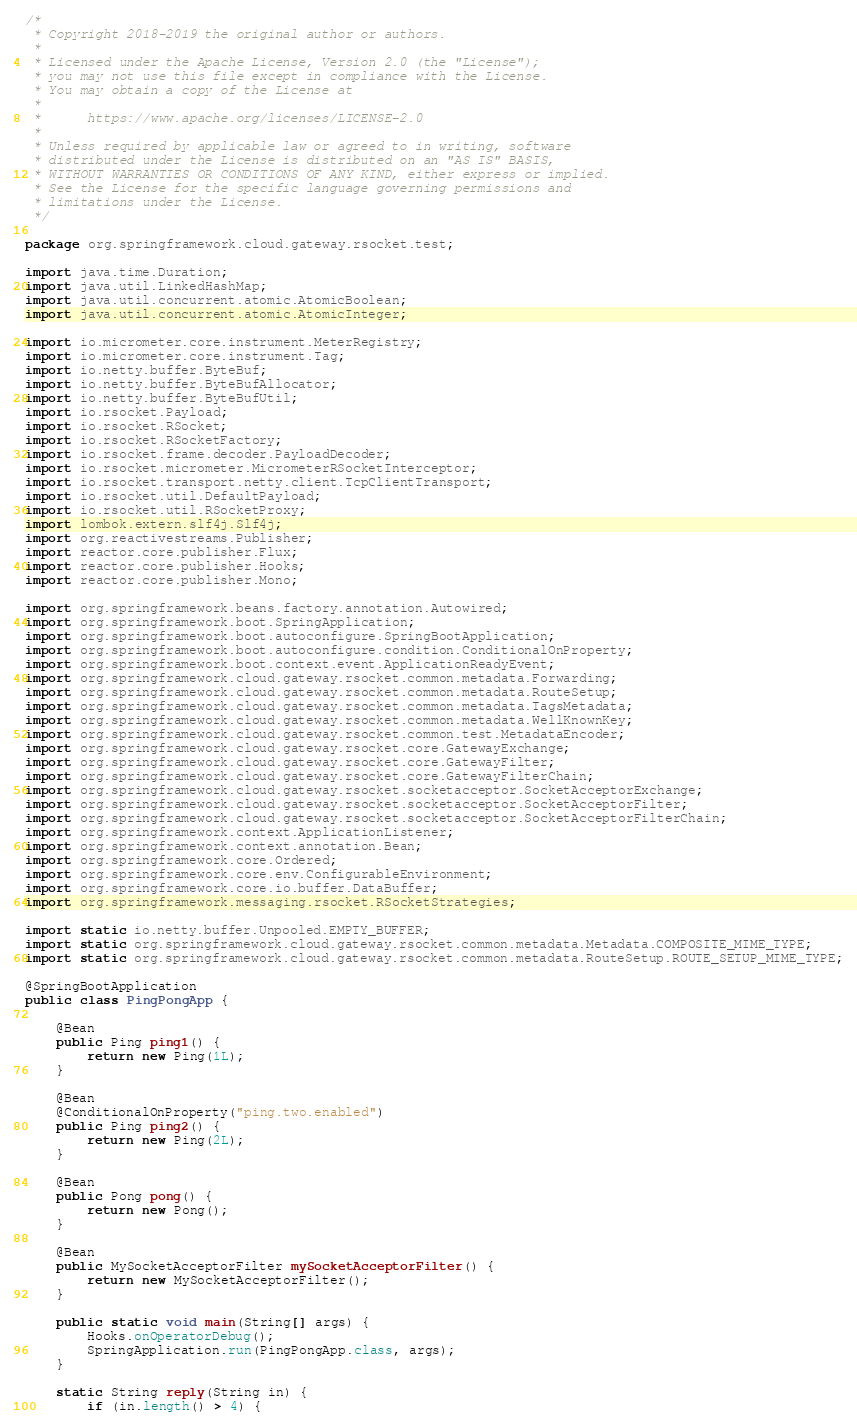Convert code to text. <code><loc_0><loc_0><loc_500><loc_500><_Java_>/*
 * Copyright 2018-2019 the original author or authors.
 *
 * Licensed under the Apache License, Version 2.0 (the "License");
 * you may not use this file except in compliance with the License.
 * You may obtain a copy of the License at
 *
 *      https://www.apache.org/licenses/LICENSE-2.0
 *
 * Unless required by applicable law or agreed to in writing, software
 * distributed under the License is distributed on an "AS IS" BASIS,
 * WITHOUT WARRANTIES OR CONDITIONS OF ANY KIND, either express or implied.
 * See the License for the specific language governing permissions and
 * limitations under the License.
 */

package org.springframework.cloud.gateway.rsocket.test;

import java.time.Duration;
import java.util.LinkedHashMap;
import java.util.concurrent.atomic.AtomicBoolean;
import java.util.concurrent.atomic.AtomicInteger;

import io.micrometer.core.instrument.MeterRegistry;
import io.micrometer.core.instrument.Tag;
import io.netty.buffer.ByteBuf;
import io.netty.buffer.ByteBufAllocator;
import io.netty.buffer.ByteBufUtil;
import io.rsocket.Payload;
import io.rsocket.RSocket;
import io.rsocket.RSocketFactory;
import io.rsocket.frame.decoder.PayloadDecoder;
import io.rsocket.micrometer.MicrometerRSocketInterceptor;
import io.rsocket.transport.netty.client.TcpClientTransport;
import io.rsocket.util.DefaultPayload;
import io.rsocket.util.RSocketProxy;
import lombok.extern.slf4j.Slf4j;
import org.reactivestreams.Publisher;
import reactor.core.publisher.Flux;
import reactor.core.publisher.Hooks;
import reactor.core.publisher.Mono;

import org.springframework.beans.factory.annotation.Autowired;
import org.springframework.boot.SpringApplication;
import org.springframework.boot.autoconfigure.SpringBootApplication;
import org.springframework.boot.autoconfigure.condition.ConditionalOnProperty;
import org.springframework.boot.context.event.ApplicationReadyEvent;
import org.springframework.cloud.gateway.rsocket.common.metadata.Forwarding;
import org.springframework.cloud.gateway.rsocket.common.metadata.RouteSetup;
import org.springframework.cloud.gateway.rsocket.common.metadata.TagsMetadata;
import org.springframework.cloud.gateway.rsocket.common.metadata.WellKnownKey;
import org.springframework.cloud.gateway.rsocket.common.test.MetadataEncoder;
import org.springframework.cloud.gateway.rsocket.core.GatewayExchange;
import org.springframework.cloud.gateway.rsocket.core.GatewayFilter;
import org.springframework.cloud.gateway.rsocket.core.GatewayFilterChain;
import org.springframework.cloud.gateway.rsocket.socketacceptor.SocketAcceptorExchange;
import org.springframework.cloud.gateway.rsocket.socketacceptor.SocketAcceptorFilter;
import org.springframework.cloud.gateway.rsocket.socketacceptor.SocketAcceptorFilterChain;
import org.springframework.context.ApplicationListener;
import org.springframework.context.annotation.Bean;
import org.springframework.core.Ordered;
import org.springframework.core.env.ConfigurableEnvironment;
import org.springframework.core.io.buffer.DataBuffer;
import org.springframework.messaging.rsocket.RSocketStrategies;

import static io.netty.buffer.Unpooled.EMPTY_BUFFER;
import static org.springframework.cloud.gateway.rsocket.common.metadata.Metadata.COMPOSITE_MIME_TYPE;
import static org.springframework.cloud.gateway.rsocket.common.metadata.RouteSetup.ROUTE_SETUP_MIME_TYPE;

@SpringBootApplication
public class PingPongApp {

	@Bean
	public Ping ping1() {
		return new Ping(1L);
	}

	@Bean
	@ConditionalOnProperty("ping.two.enabled")
	public Ping ping2() {
		return new Ping(2L);
	}

	@Bean
	public Pong pong() {
		return new Pong();
	}

	@Bean
	public MySocketAcceptorFilter mySocketAcceptorFilter() {
		return new MySocketAcceptorFilter();
	}

	public static void main(String[] args) {
		Hooks.onOperatorDebug();
		SpringApplication.run(PingPongApp.class, args);
	}

	static String reply(String in) {
		if (in.length() > 4) {</code> 